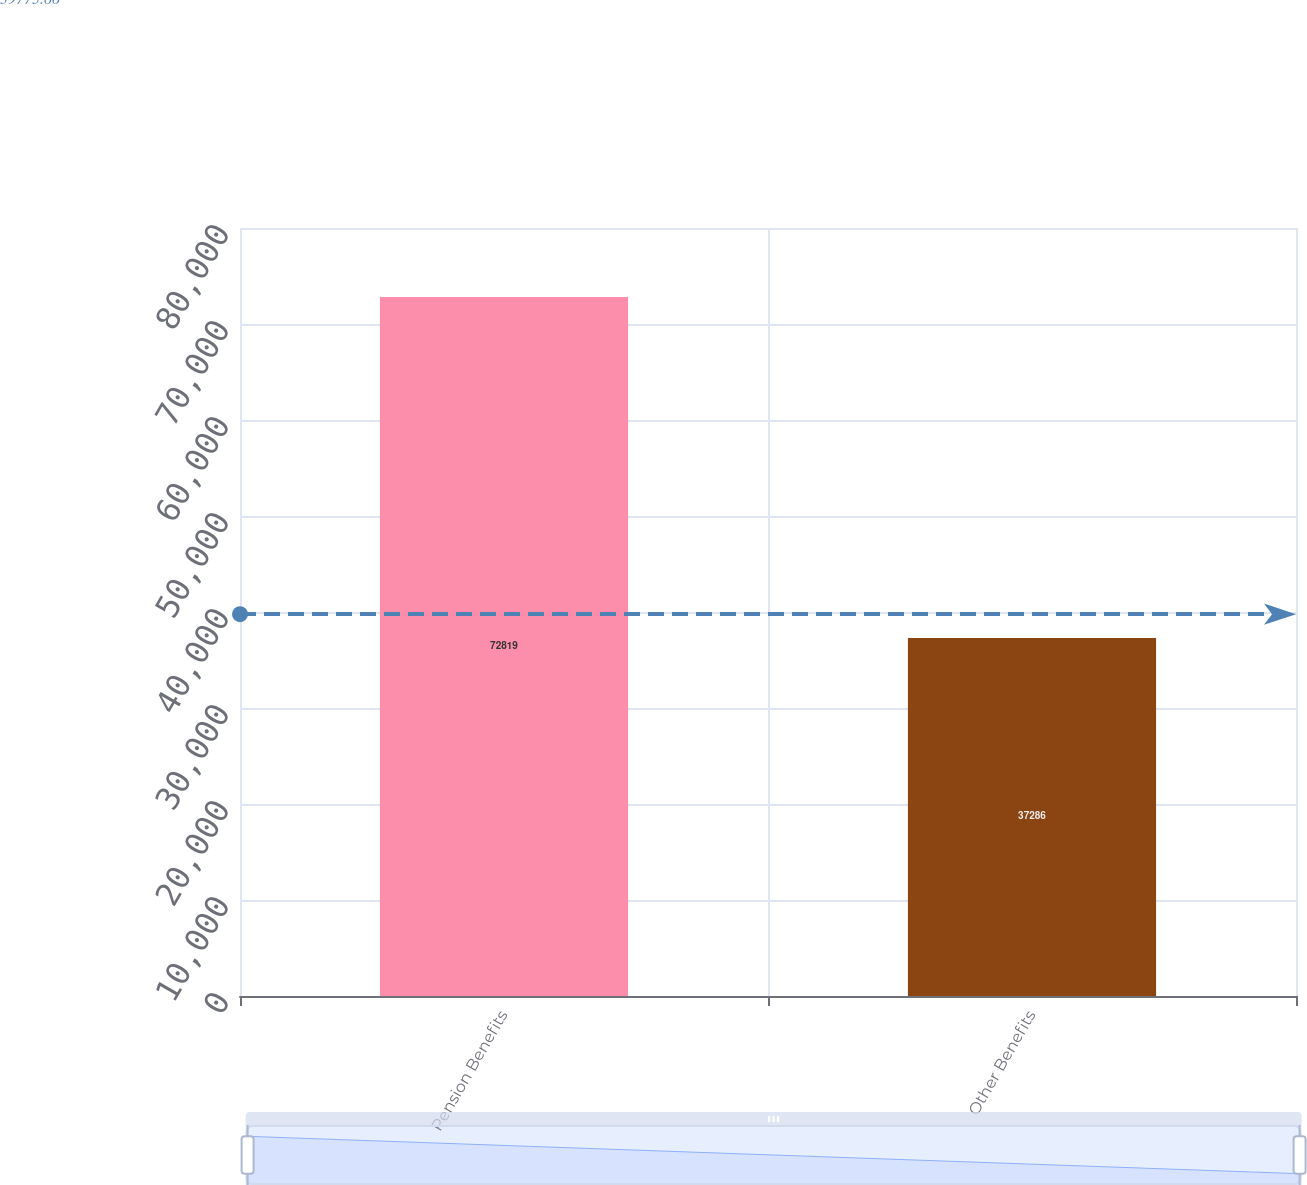<chart> <loc_0><loc_0><loc_500><loc_500><bar_chart><fcel>Pension Benefits<fcel>Other Benefits<nl><fcel>72819<fcel>37286<nl></chart> 